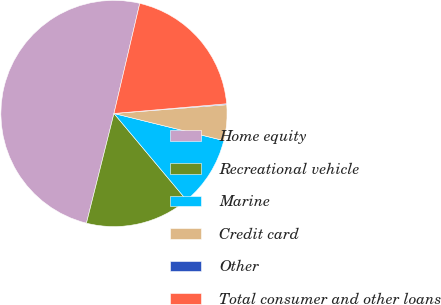<chart> <loc_0><loc_0><loc_500><loc_500><pie_chart><fcel>Home equity<fcel>Recreational vehicle<fcel>Marine<fcel>Credit card<fcel>Other<fcel>Total consumer and other loans<nl><fcel>49.75%<fcel>15.01%<fcel>10.05%<fcel>5.09%<fcel>0.13%<fcel>19.97%<nl></chart> 